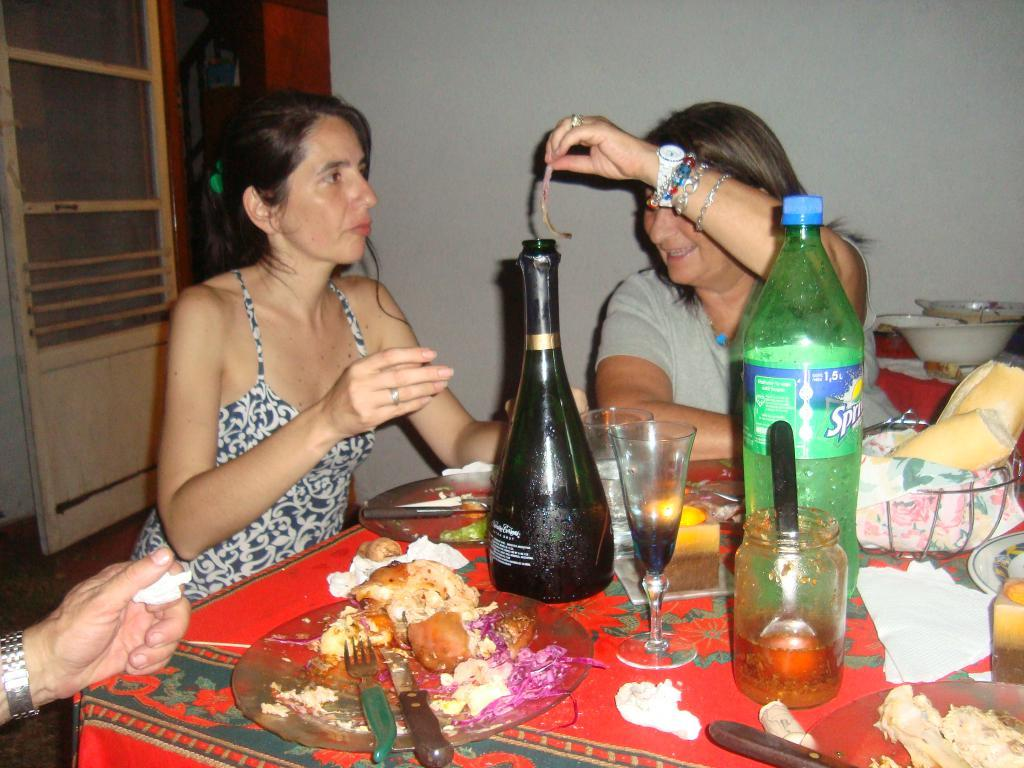<image>
Provide a brief description of the given image. A group of people sit around a messy dining table with a bottle of Sprite in the middle. 